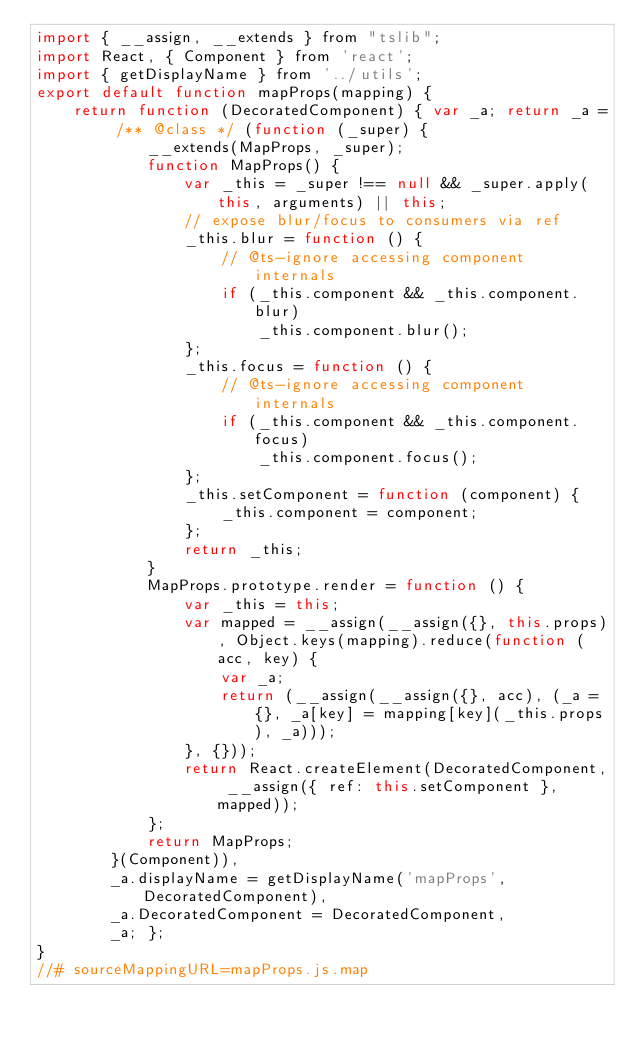<code> <loc_0><loc_0><loc_500><loc_500><_JavaScript_>import { __assign, __extends } from "tslib";
import React, { Component } from 'react';
import { getDisplayName } from '../utils';
export default function mapProps(mapping) {
    return function (DecoratedComponent) { var _a; return _a = /** @class */ (function (_super) {
            __extends(MapProps, _super);
            function MapProps() {
                var _this = _super !== null && _super.apply(this, arguments) || this;
                // expose blur/focus to consumers via ref
                _this.blur = function () {
                    // @ts-ignore accessing component internals
                    if (_this.component && _this.component.blur)
                        _this.component.blur();
                };
                _this.focus = function () {
                    // @ts-ignore accessing component internals
                    if (_this.component && _this.component.focus)
                        _this.component.focus();
                };
                _this.setComponent = function (component) {
                    _this.component = component;
                };
                return _this;
            }
            MapProps.prototype.render = function () {
                var _this = this;
                var mapped = __assign(__assign({}, this.props), Object.keys(mapping).reduce(function (acc, key) {
                    var _a;
                    return (__assign(__assign({}, acc), (_a = {}, _a[key] = mapping[key](_this.props), _a)));
                }, {}));
                return React.createElement(DecoratedComponent, __assign({ ref: this.setComponent }, mapped));
            };
            return MapProps;
        }(Component)),
        _a.displayName = getDisplayName('mapProps', DecoratedComponent),
        _a.DecoratedComponent = DecoratedComponent,
        _a; };
}
//# sourceMappingURL=mapProps.js.map</code> 